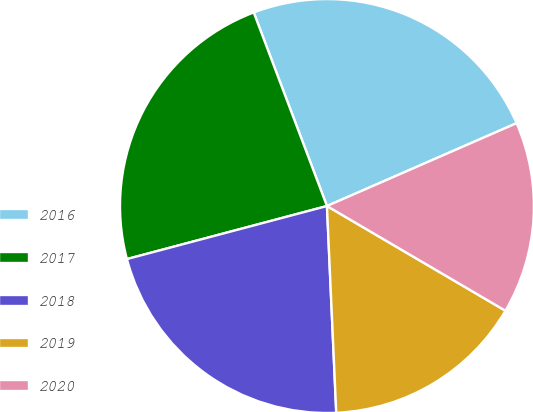Convert chart. <chart><loc_0><loc_0><loc_500><loc_500><pie_chart><fcel>2016<fcel>2017<fcel>2018<fcel>2019<fcel>2020<nl><fcel>24.2%<fcel>23.37%<fcel>21.59%<fcel>15.84%<fcel>15.0%<nl></chart> 